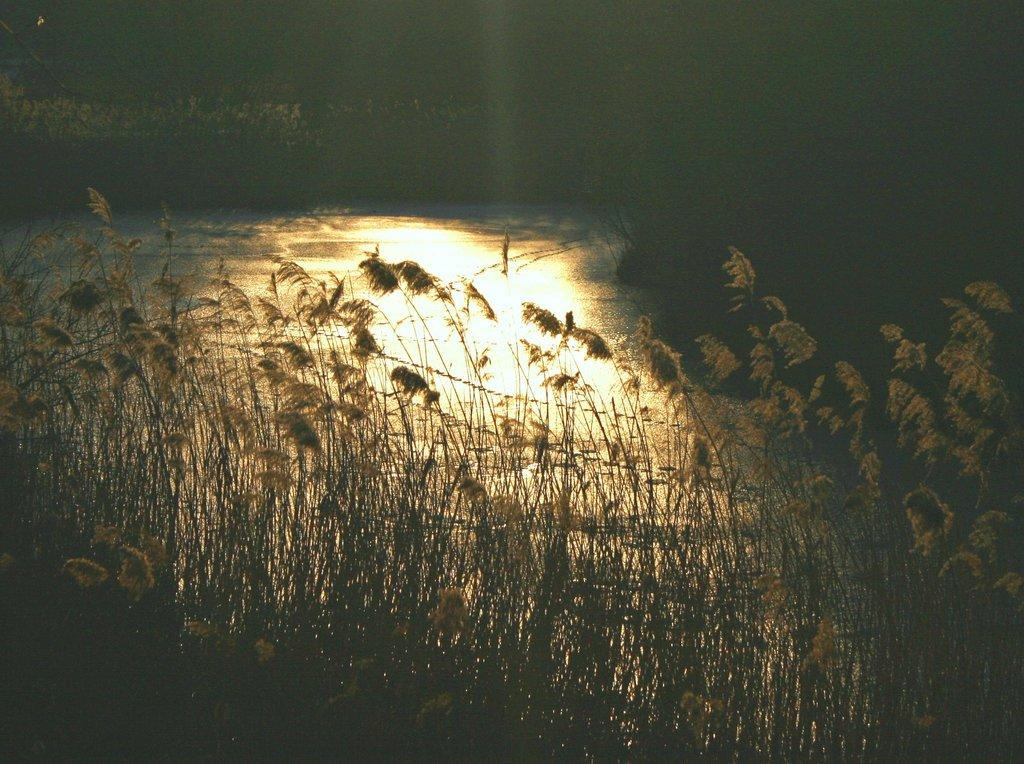What type of living organisms can be seen in the image? Plants can be seen in the image. What is the primary element visible in the image? Water is visible in the image. What type of gold object can be seen in the image? There is no gold object present in the image. 